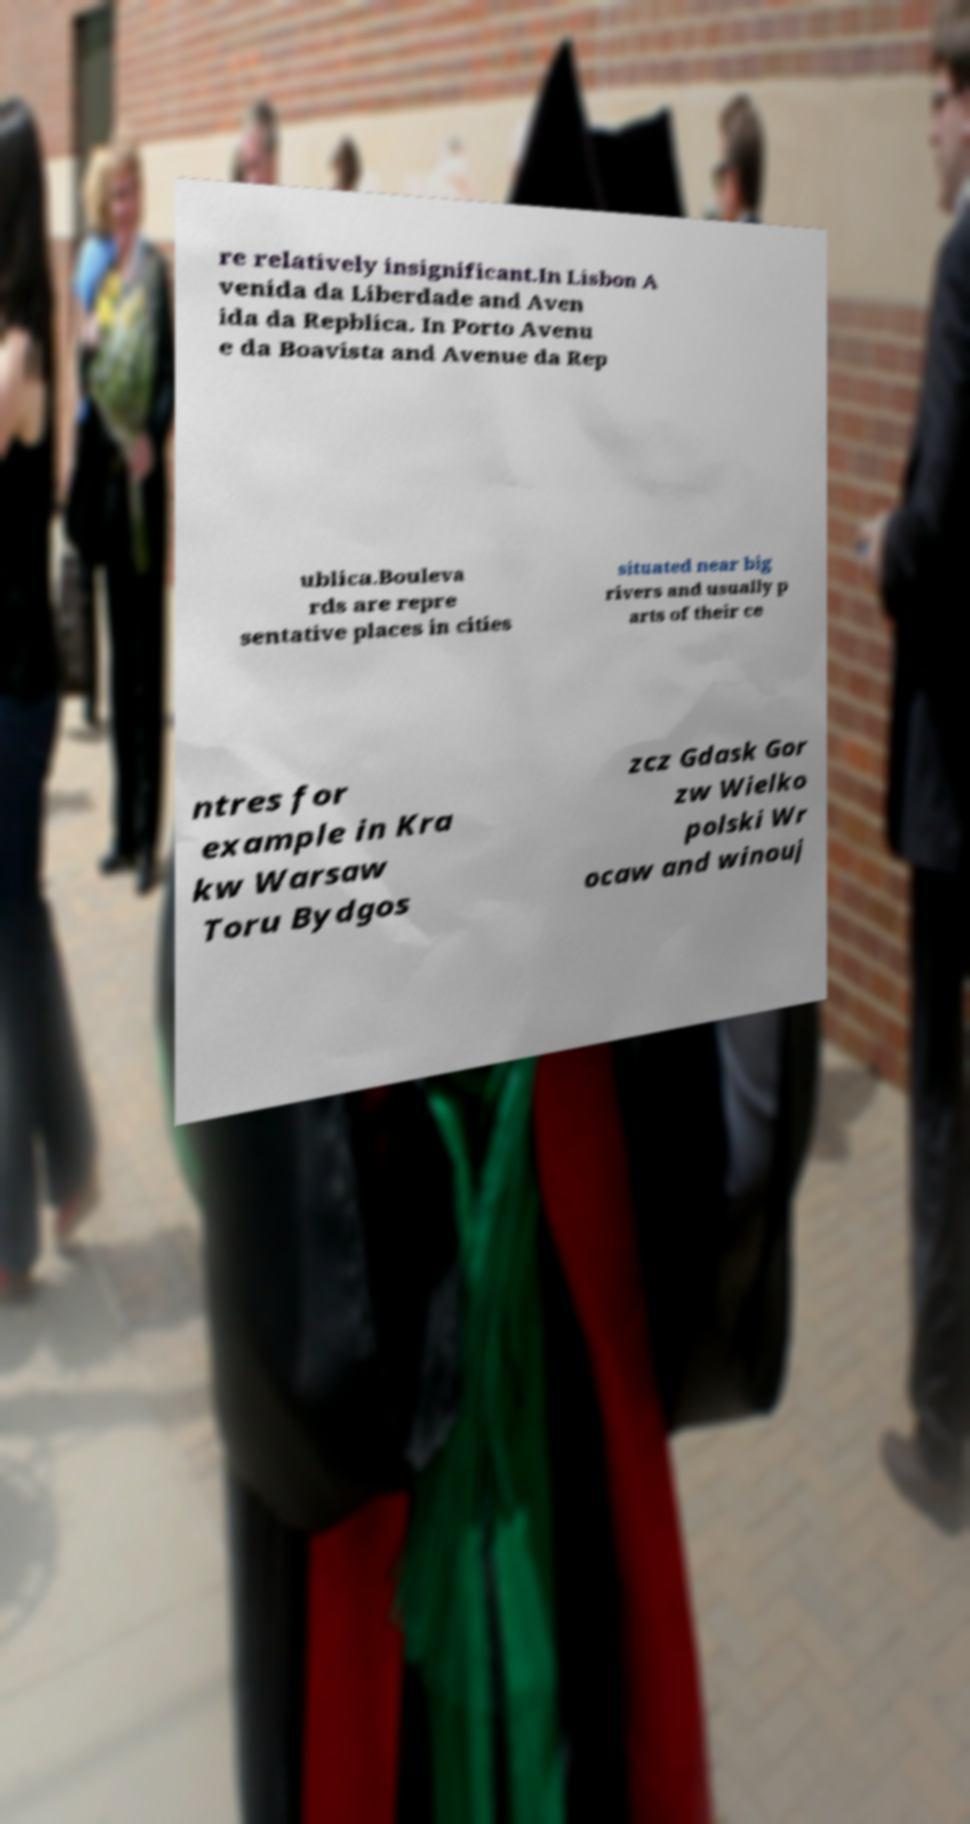Could you extract and type out the text from this image? re relatively insignificant.In Lisbon A venida da Liberdade and Aven ida da Repblica. In Porto Avenu e da Boavista and Avenue da Rep ublica.Bouleva rds are repre sentative places in cities situated near big rivers and usually p arts of their ce ntres for example in Kra kw Warsaw Toru Bydgos zcz Gdask Gor zw Wielko polski Wr ocaw and winouj 